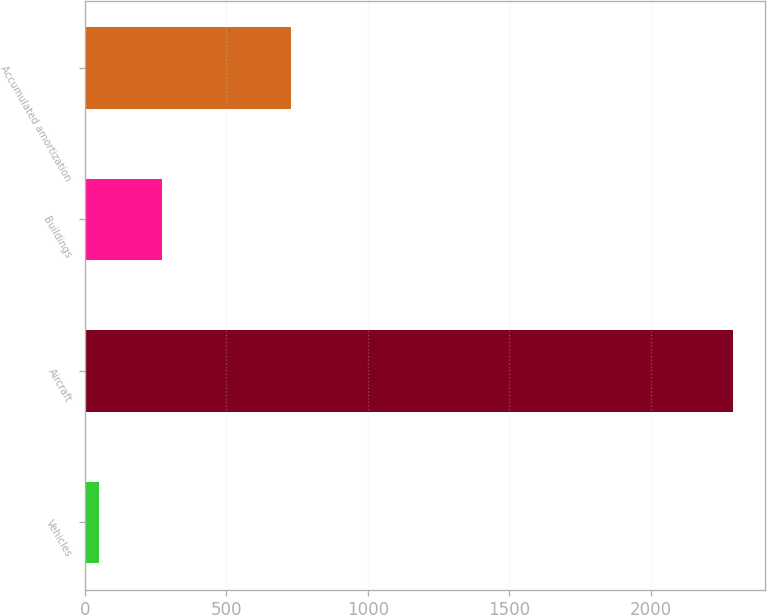Convert chart to OTSL. <chart><loc_0><loc_0><loc_500><loc_500><bar_chart><fcel>Vehicles<fcel>Aircraft<fcel>Buildings<fcel>Accumulated amortization<nl><fcel>49<fcel>2289<fcel>273<fcel>727<nl></chart> 